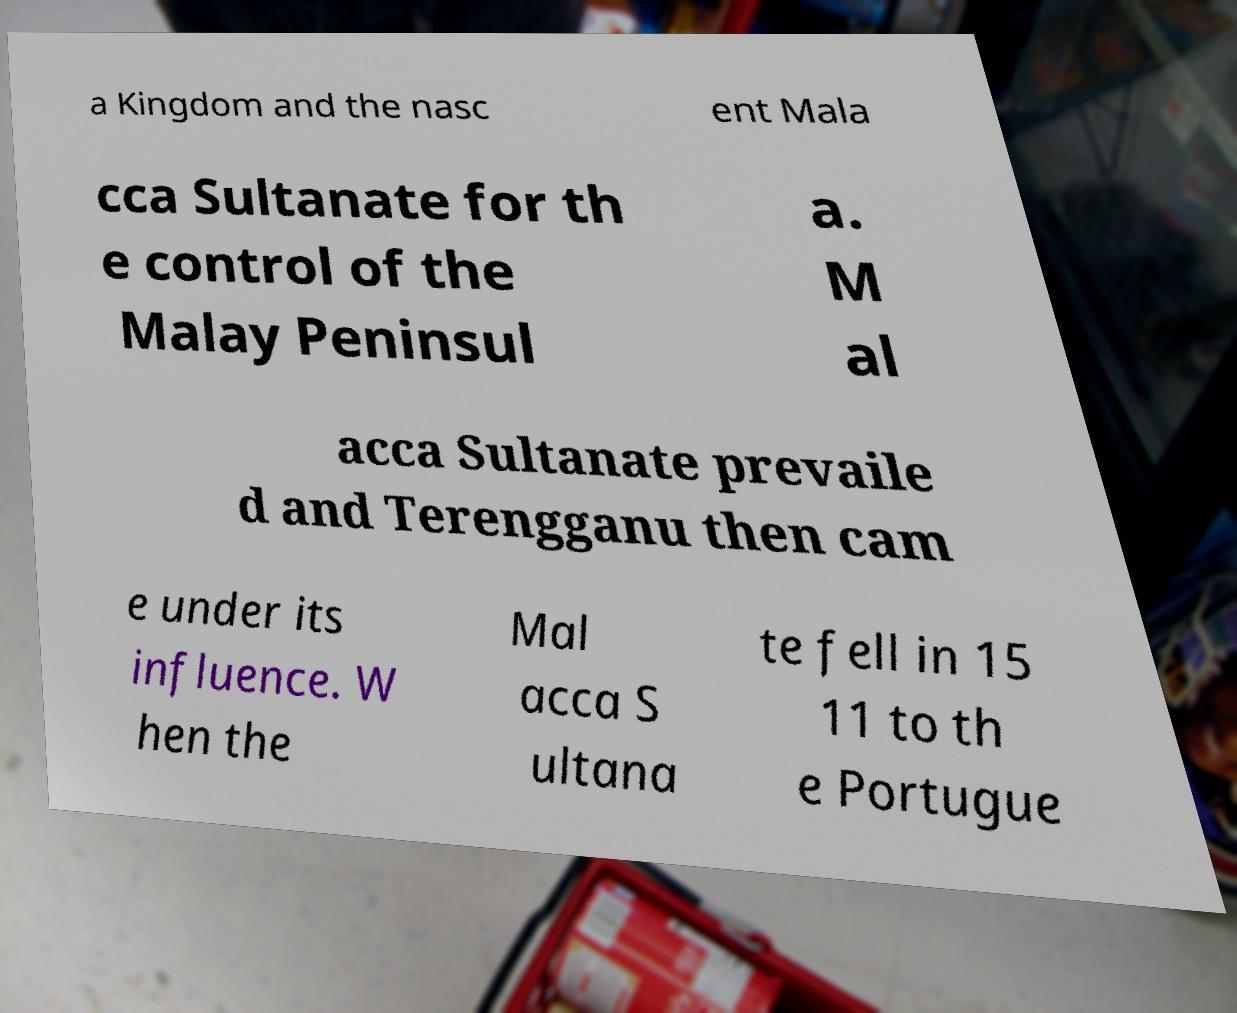Can you read and provide the text displayed in the image?This photo seems to have some interesting text. Can you extract and type it out for me? a Kingdom and the nasc ent Mala cca Sultanate for th e control of the Malay Peninsul a. M al acca Sultanate prevaile d and Terengganu then cam e under its influence. W hen the Mal acca S ultana te fell in 15 11 to th e Portugue 